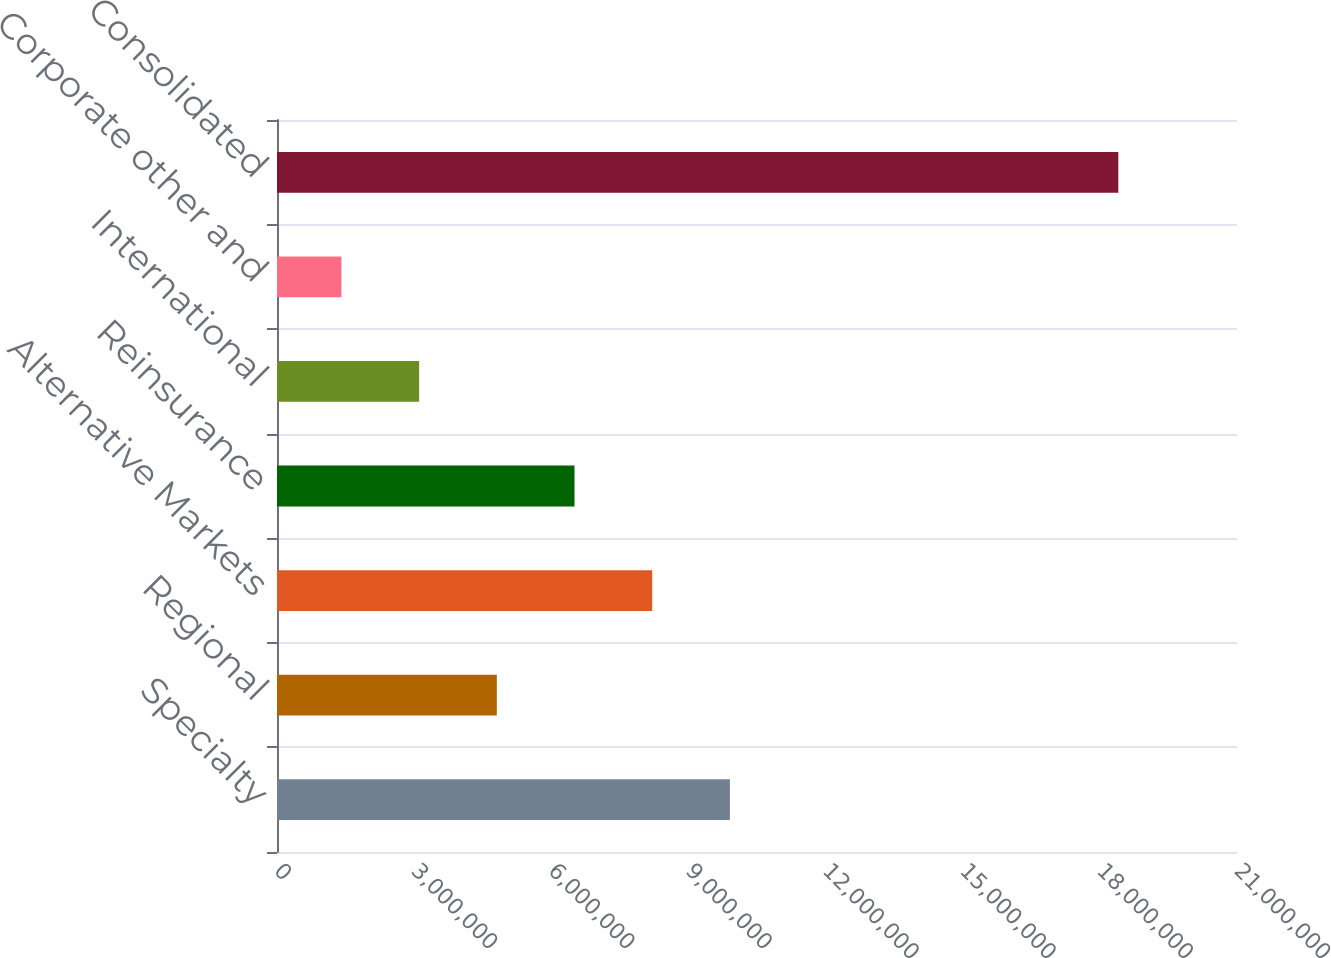<chart> <loc_0><loc_0><loc_500><loc_500><bar_chart><fcel>Specialty<fcel>Regional<fcel>Alternative Markets<fcel>Reinsurance<fcel>International<fcel>Corporate other and<fcel>Consolidated<nl><fcel>9.9069e+06<fcel>4.80872e+06<fcel>8.20751e+06<fcel>6.50811e+06<fcel>3.10932e+06<fcel>1.40993e+06<fcel>1.84039e+07<nl></chart> 